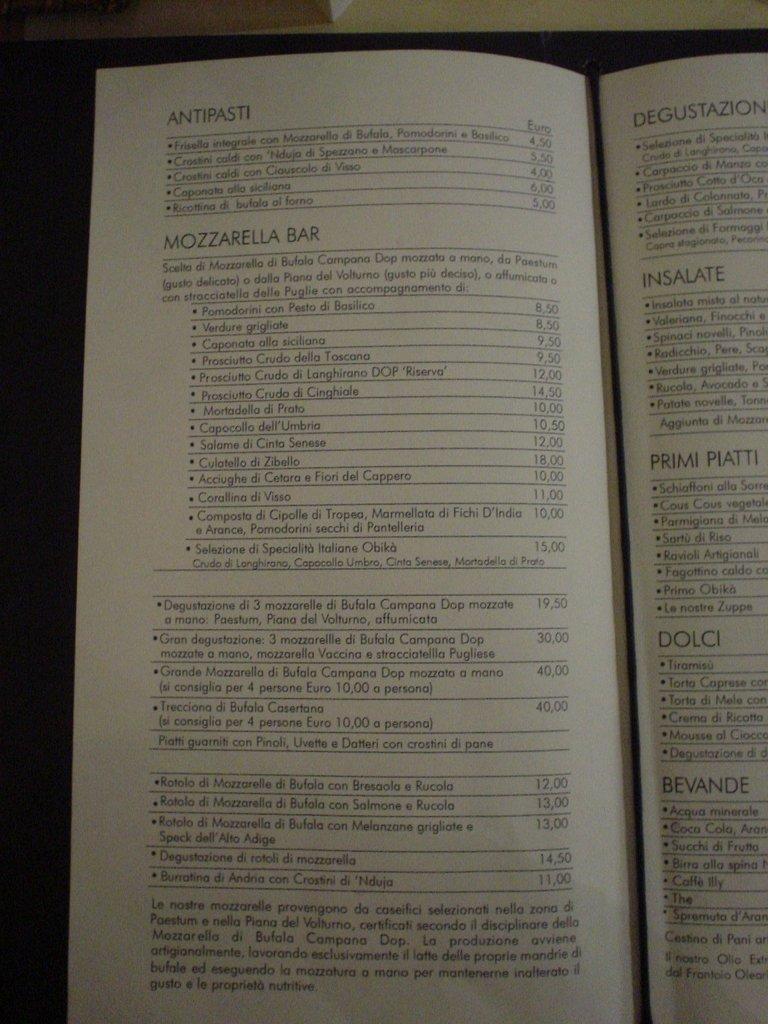How much is the least expensive antipasta?
Make the answer very short. Unanswerable. What word is printed at the top left of the page?
Give a very brief answer. Antipasti. 